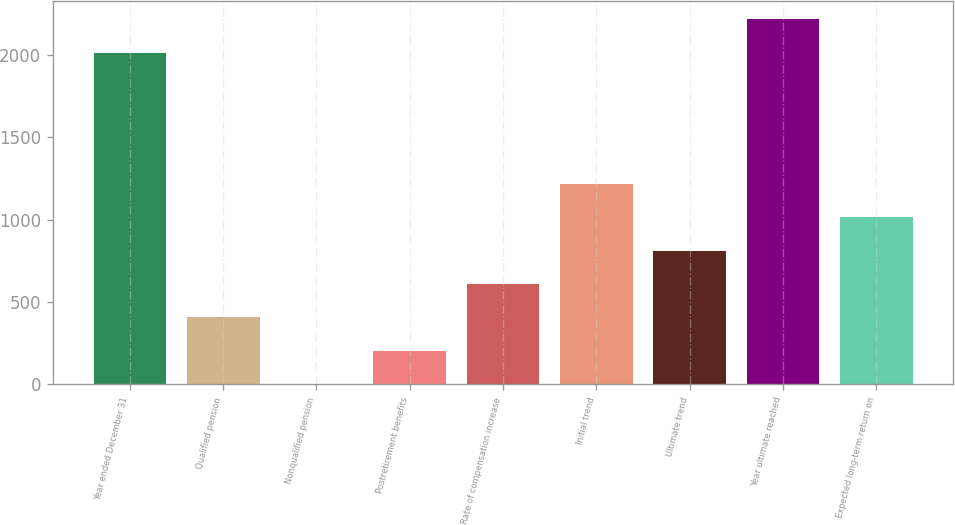Convert chart. <chart><loc_0><loc_0><loc_500><loc_500><bar_chart><fcel>Year ended December 31<fcel>Qualified pension<fcel>Nonqualified pension<fcel>Postretirement benefits<fcel>Rate of compensation increase<fcel>Initial trend<fcel>Ultimate trend<fcel>Year ultimate reached<fcel>Expected long-term return on<nl><fcel>2015<fcel>407.91<fcel>3.65<fcel>205.78<fcel>610.05<fcel>1216.44<fcel>812.18<fcel>2217.14<fcel>1014.31<nl></chart> 